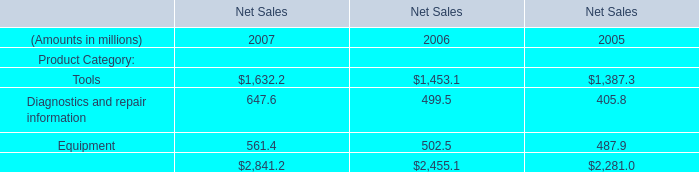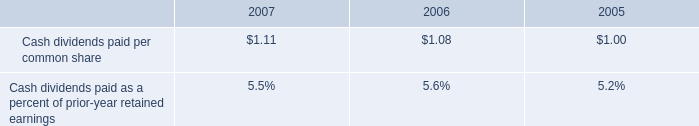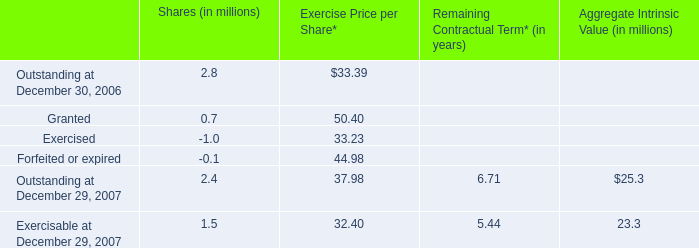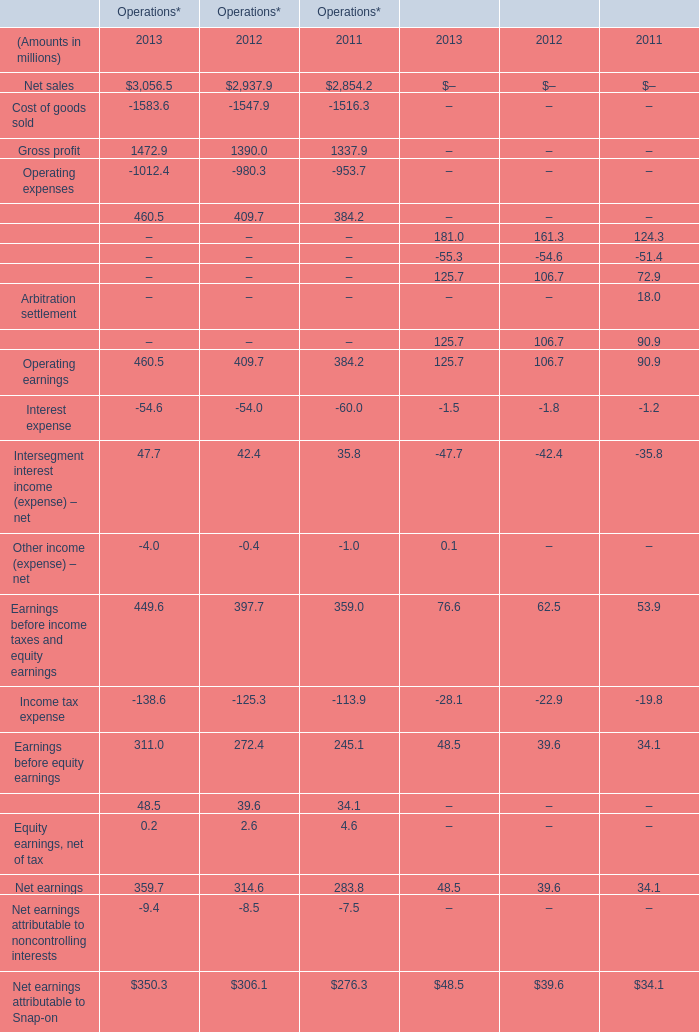What was the average of Operating earnings in 2011,2012 and 2013 for operations (in million) 
Computations: (((460.5 + 409.7) + 384.2) / 3)
Answer: 418.13333. 